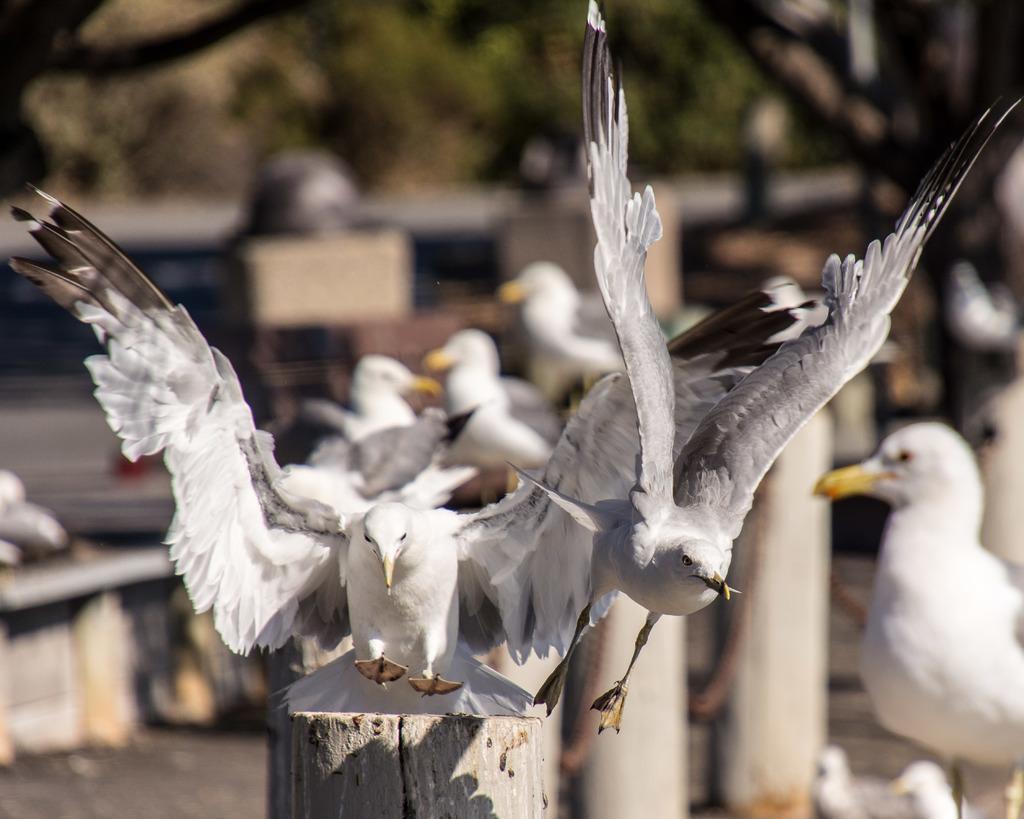Can you describe this image briefly? This is an outside view. At the bottom there are few wooden poles and there are many birds. At the top of the image the leaves are visible. The background is blurred. 